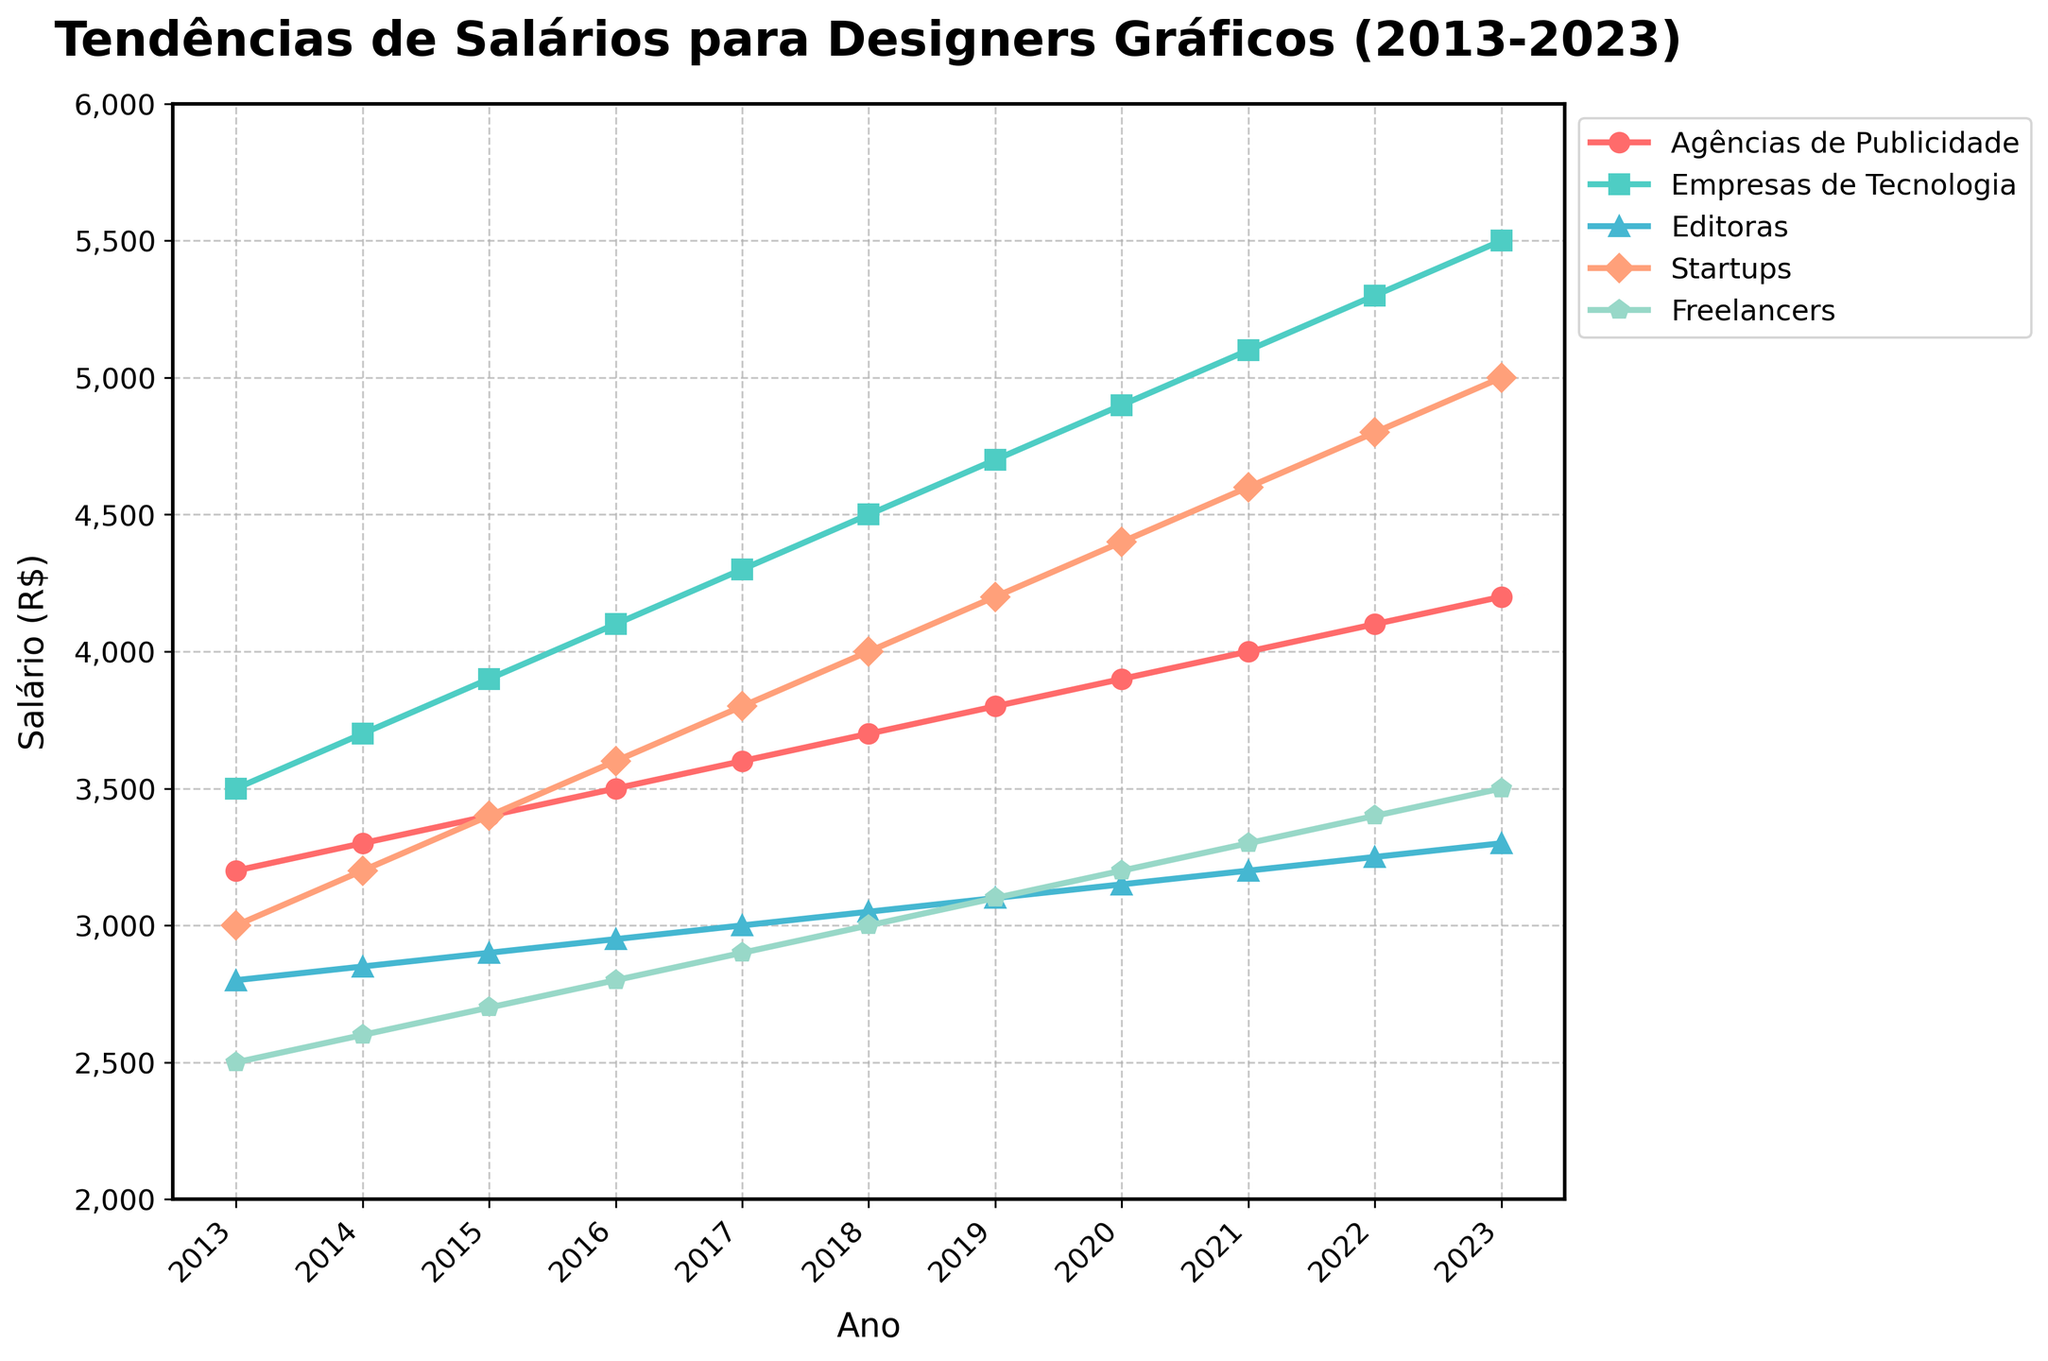What setor teve o maior aumento salarial absoluto entre 2013 e 2023? Para descobrir o setor com o maior aumento salarial absoluto, subtrai-se o salário de 2013 do salário de 2023 para cada setor. O cálculo é: Agências de Publicidade: 4200 - 3200 = 1000, Empresas de Tecnologia: 5500 - 3500 = 2000, Editoras: 3300 - 2800 = 500, Startups: 5000 - 3000 = 2000, Freelancers: 3500 - 2500 = 1000. Os maiores aumentos foram em Empresas de Tecnologia e Startups, ambos com aumento de 2000.
Answer: Empresas de Tecnologia e Startups Qual setor teve o menor salário em 2023? Para identificar o setor com o menor salário em 2023, basta observar os valores salariais daquele ano: Agências de Publicidade: 4200, Empresas de Tecnologia: 5500, Editoras: 3300, Startups: 5000, Freelancers: 3500. O menor salário é de 3300 (Editoras).
Answer: Editoras Qual a média salarial dos designers freelancers ao longo dos anos estudados? Para calcular a média salarial dos freelancers, some os salários de todos os anos e divida pelo número de anos. (2500 + 2600 + 2700 + 2800 + 2900 + 3000 + 3100 + 3200 + 3300 + 3400 + 3500) = 35200. Dividindo por 11 o resultado é: 35200/11 = 3200.
Answer: 3200 Em que ano os salários das editoras ultrapassaram 3000 pela primeira vez? Acompanhe os valores salariais das editoras ao longo dos anos até encontrar um salário maior que 3000: 2013: 2800, 2014: 2850, 2015: 2900, 2016: 2950, 2017: 3000, 2018: 3050. O salário ultrapassou 3000 em 2018.
Answer: 2018 Qual setor teve o crescimento salarial mais consistente ao longo dos anos? Consistência pode ser medida pela regularidade dos aumentos salariais. Observando os gráficos, Empresas de Tecnologia mostram aumentos anuais regulares a cada ano sem queda ou estagnação: 3500, 3700, 3900, 4100, 4300, 4500, 4700, 4900, 5100, 5300, 5500.
Answer: Empresas de Tecnologia 